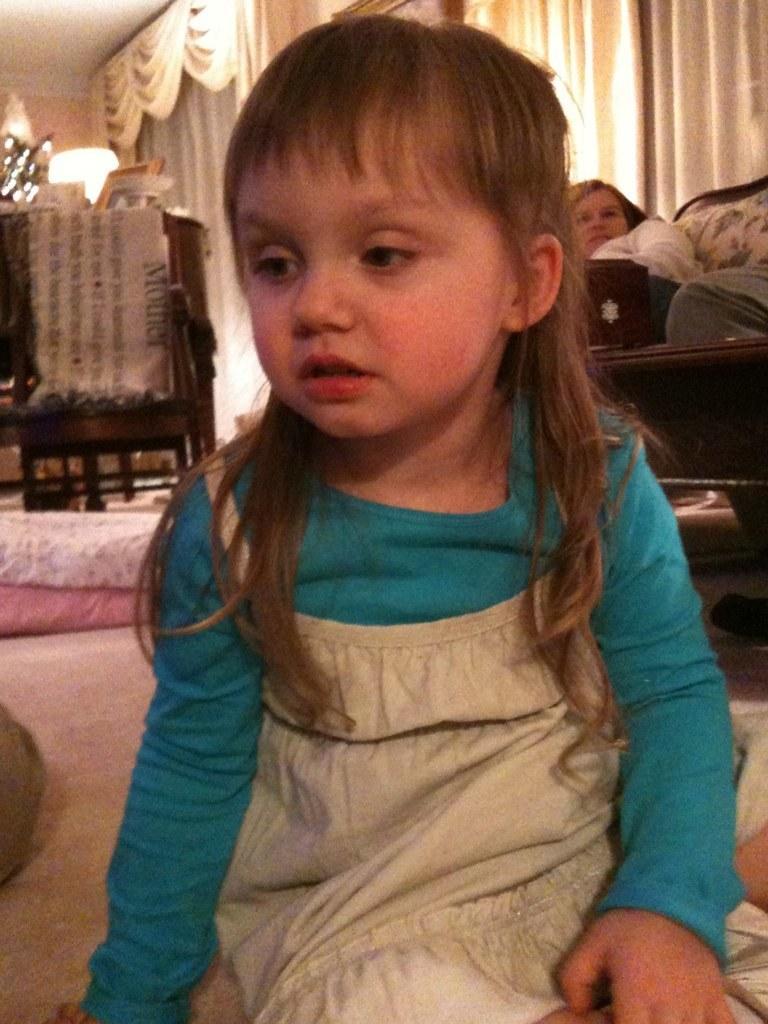How would you summarize this image in a sentence or two? In this image in the front there is a girl sitting. In the background there is an empty chair. On the right side there are persons sitting on the sofa, there are curtains which are white in colour and there is a table, on the table there are objects and there are pillows on the ground. 